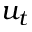Convert formula to latex. <formula><loc_0><loc_0><loc_500><loc_500>u _ { t }</formula> 